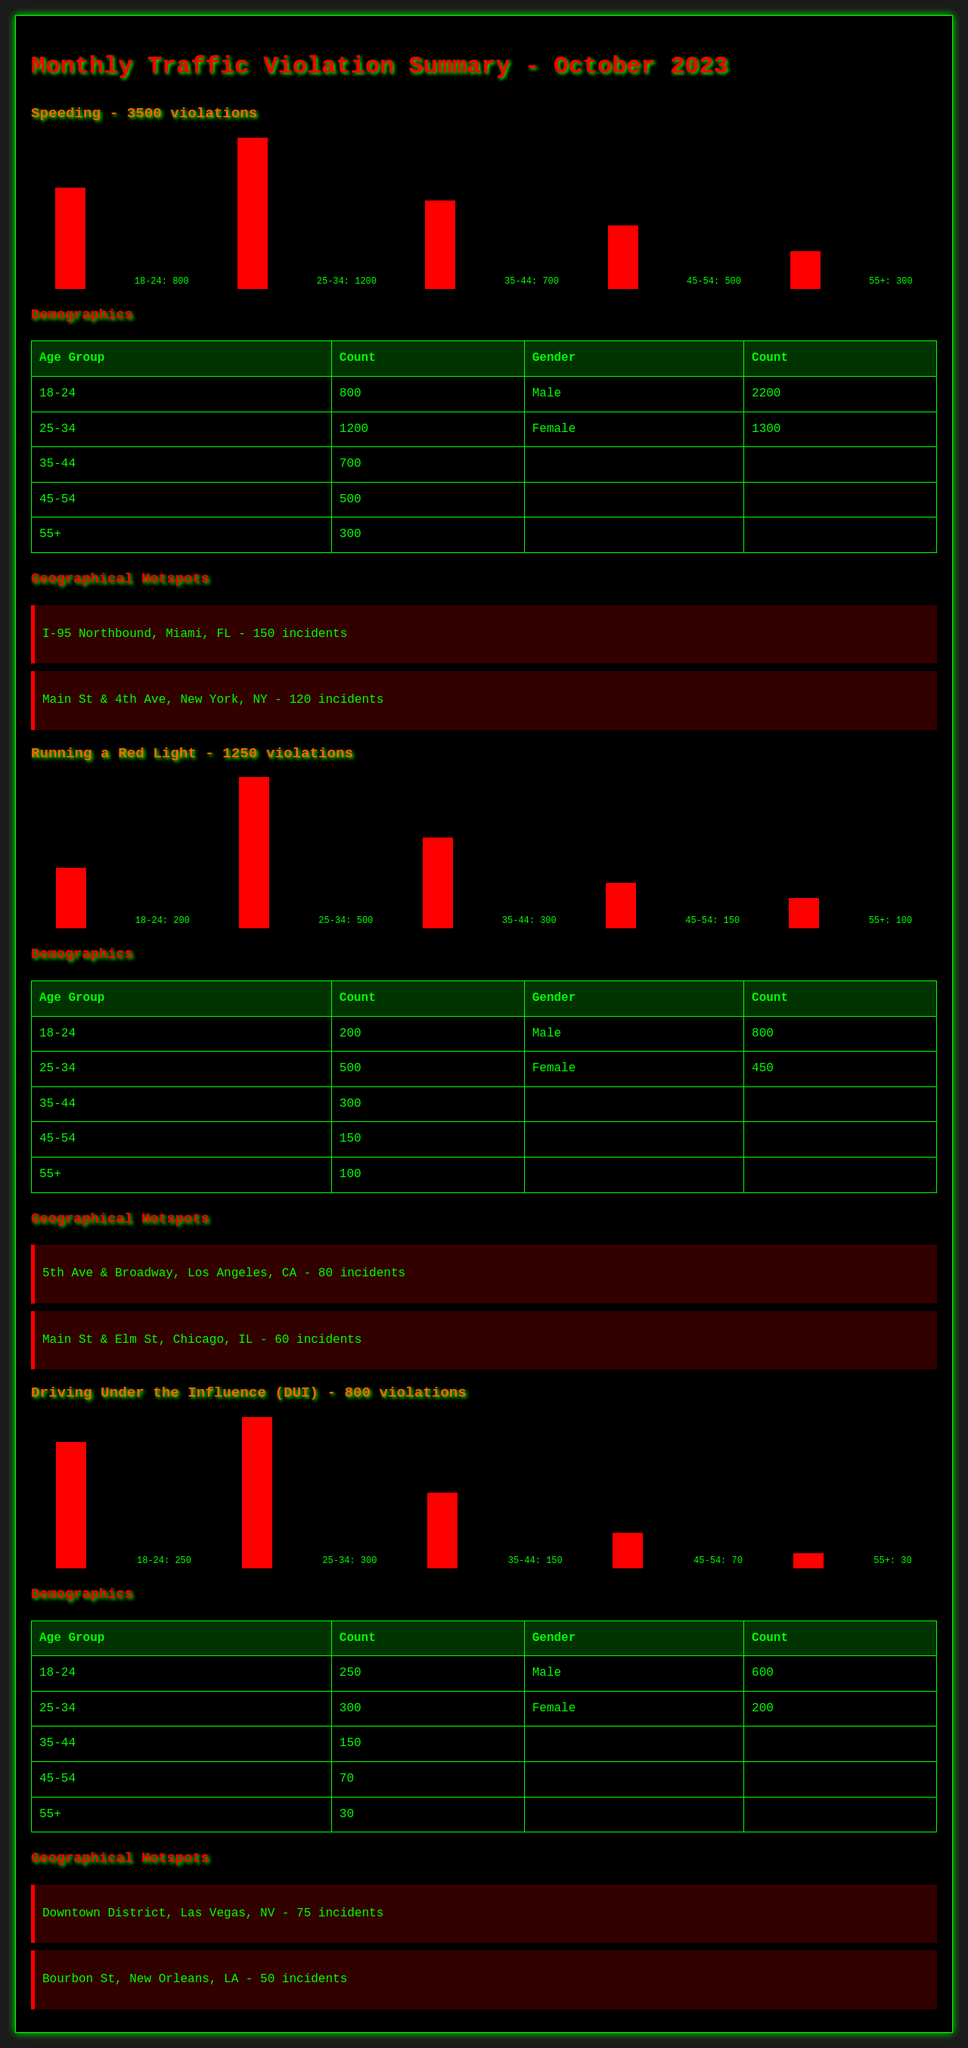what was the total number of speeding violations? The total number of speeding violations is mentioned in the document, which is 3500 violations.
Answer: 3500 violations how many DUI violations were recorded? The number of Driving Under the Influence violations is specified in the document.
Answer: 800 violations which age group had the highest number of offenses for red light violations? By comparing the age groups in the red light violations demographic table, it can be determined that the 25-34 age group had the highest number of offenses with 500.
Answer: 25-34 what is the most common gender among DUI offenders? The document indicates that for DUI violations, more males were recorded than females, with 600 males compared to 200 females.
Answer: Male how many incidents occurred at I-95 Northbound, Miami, FL? The document specifies that there were 150 incidents at I-95 Northbound, Miami, FL.
Answer: 150 incidents which violation type had the fewest recorded incidents? By looking at the total violations, it is clear that the violation with the fewest recorded incidents is running a red light, with 1250 total violations.
Answer: 1250 violations who had more violations in the age group 18-24 for speeding? The demographic table for speeding shows that males had more violations in the age group 18-24 with 2200 violations.
Answer: Male what area had the highest number of hotspot incidents for DUI violations? According to the hotspots section, the Downtown District, Las Vegas, NV had the highest number of incidents for DUI violations with 75.
Answer: Downtown District, Las Vegas, NV how many incidents were reported at 5th Ave & Broadway, Los Angeles, CA? The document states that there were 80 incidents reported at 5th Ave & Broadway, Los Angeles, CA.
Answer: 80 incidents 